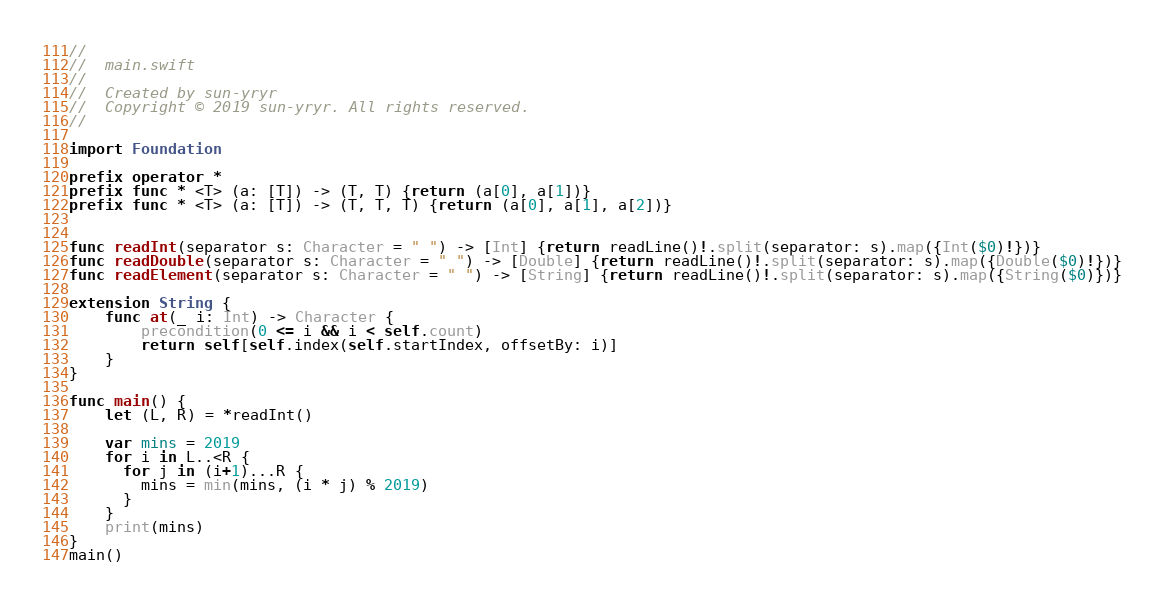<code> <loc_0><loc_0><loc_500><loc_500><_Swift_>//
//  main.swift
//
//  Created by sun-yryr
//  Copyright © 2019 sun-yryr. All rights reserved.
//
 
import Foundation
 
prefix operator *
prefix func * <T> (a: [T]) -> (T, T) {return (a[0], a[1])}
prefix func * <T> (a: [T]) -> (T, T, T) {return (a[0], a[1], a[2])}
 
 
func readInt(separator s: Character = " ") -> [Int] {return readLine()!.split(separator: s).map({Int($0)!})}
func readDouble(separator s: Character = " ") -> [Double] {return readLine()!.split(separator: s).map({Double($0)!})}
func readElement(separator s: Character = " ") -> [String] {return readLine()!.split(separator: s).map({String($0)})}
 
extension String {
    func at(_ i: Int) -> Character {
        precondition(0 <= i && i < self.count)
        return self[self.index(self.startIndex, offsetBy: i)]
    }
}
 
func main() {
    let (L, R) = *readInt()
    
    var mins = 2019
    for i in L..<R {
      for j in (i+1)...R {
        mins = min(mins, (i * j) % 2019)
      }
    }
    print(mins)
}
main()</code> 